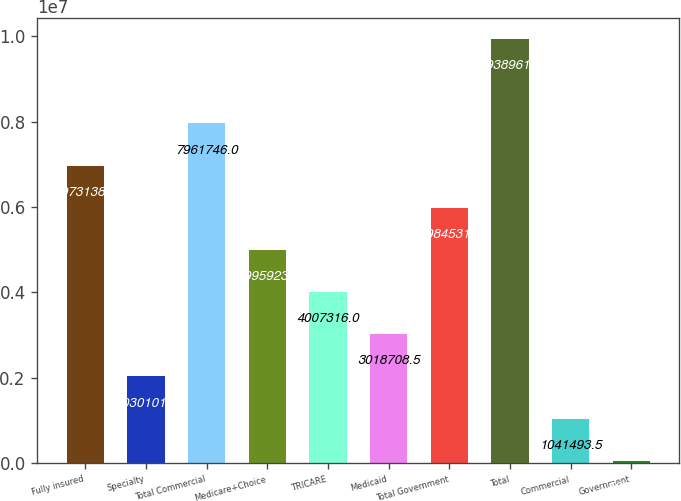Convert chart. <chart><loc_0><loc_0><loc_500><loc_500><bar_chart><fcel>Fully insured<fcel>Specialty<fcel>Total Commercial<fcel>Medicare+Choice<fcel>TRICARE<fcel>Medicaid<fcel>Total Government<fcel>Total<fcel>Commercial<fcel>Government<nl><fcel>6.97314e+06<fcel>2.0301e+06<fcel>7.96175e+06<fcel>4.99592e+06<fcel>4.00732e+06<fcel>3.01871e+06<fcel>5.98453e+06<fcel>9.93896e+06<fcel>1.04149e+06<fcel>52886<nl></chart> 